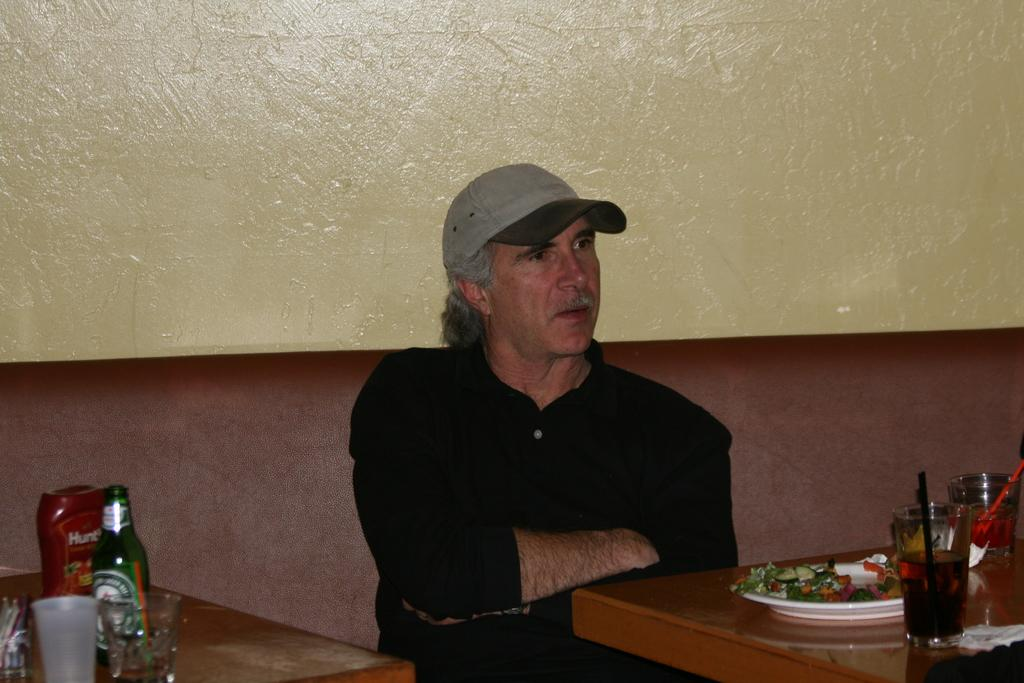What is the man in the image doing? The man is sitting in the image. In which direction is the man looking? The man is looking to the right. What objects are present in the image besides the man? There is a wine glass and a plate in the image. Can you hear the man's cry in the image? There is no indication of any sound or crying in the image, as it is a still image. 